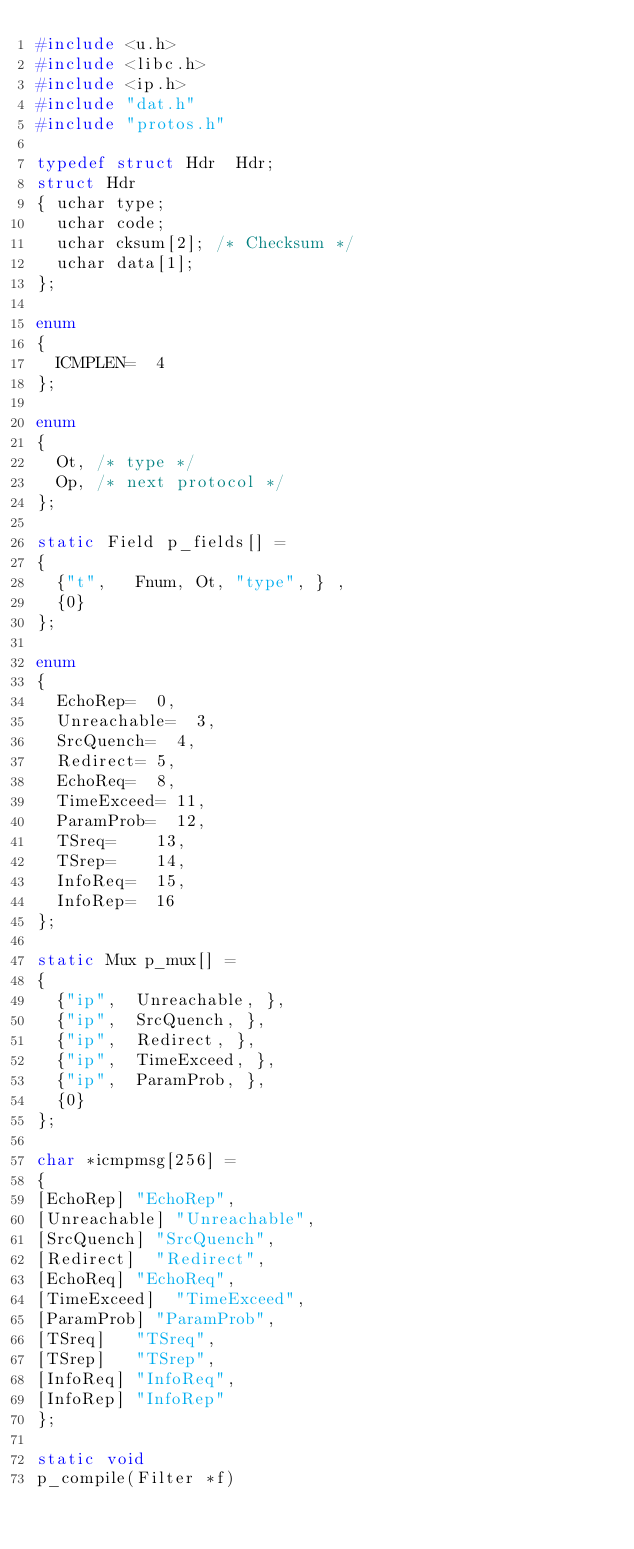<code> <loc_0><loc_0><loc_500><loc_500><_C_>#include <u.h>
#include <libc.h>
#include <ip.h>
#include "dat.h"
#include "protos.h"

typedef struct Hdr	Hdr;
struct Hdr
{	uchar	type;
	uchar	code;
	uchar	cksum[2];	/* Checksum */
	uchar	data[1];
};

enum
{
	ICMPLEN=	4
};

enum
{
	Ot,	/* type */
	Op,	/* next protocol */
};

static Field p_fields[] =
{
	{"t",		Fnum,	Ot,	"type",	} ,
	{0}
};

enum
{
	EchoRep=	0,
	Unreachable=	3,
	SrcQuench=	4,
	Redirect=	5,
	EchoReq=	8,
	TimeExceed=	11,
	ParamProb=	12,
	TSreq=		13,
	TSrep=		14,
	InfoReq=	15,
	InfoRep=	16
};

static Mux p_mux[] =
{
	{"ip",	Unreachable, },
	{"ip",	SrcQuench, },
	{"ip",	Redirect, },
	{"ip",	TimeExceed, },
	{"ip",	ParamProb, },
	{0}
};

char *icmpmsg[256] =
{
[EchoRep]	"EchoRep",
[Unreachable]	"Unreachable",
[SrcQuench]	"SrcQuench",
[Redirect]	"Redirect",
[EchoReq]	"EchoReq",
[TimeExceed]	"TimeExceed",
[ParamProb]	"ParamProb",
[TSreq]		"TSreq",
[TSrep]		"TSrep",
[InfoReq]	"InfoReq",
[InfoRep]	"InfoRep"
};

static void
p_compile(Filter *f)</code> 